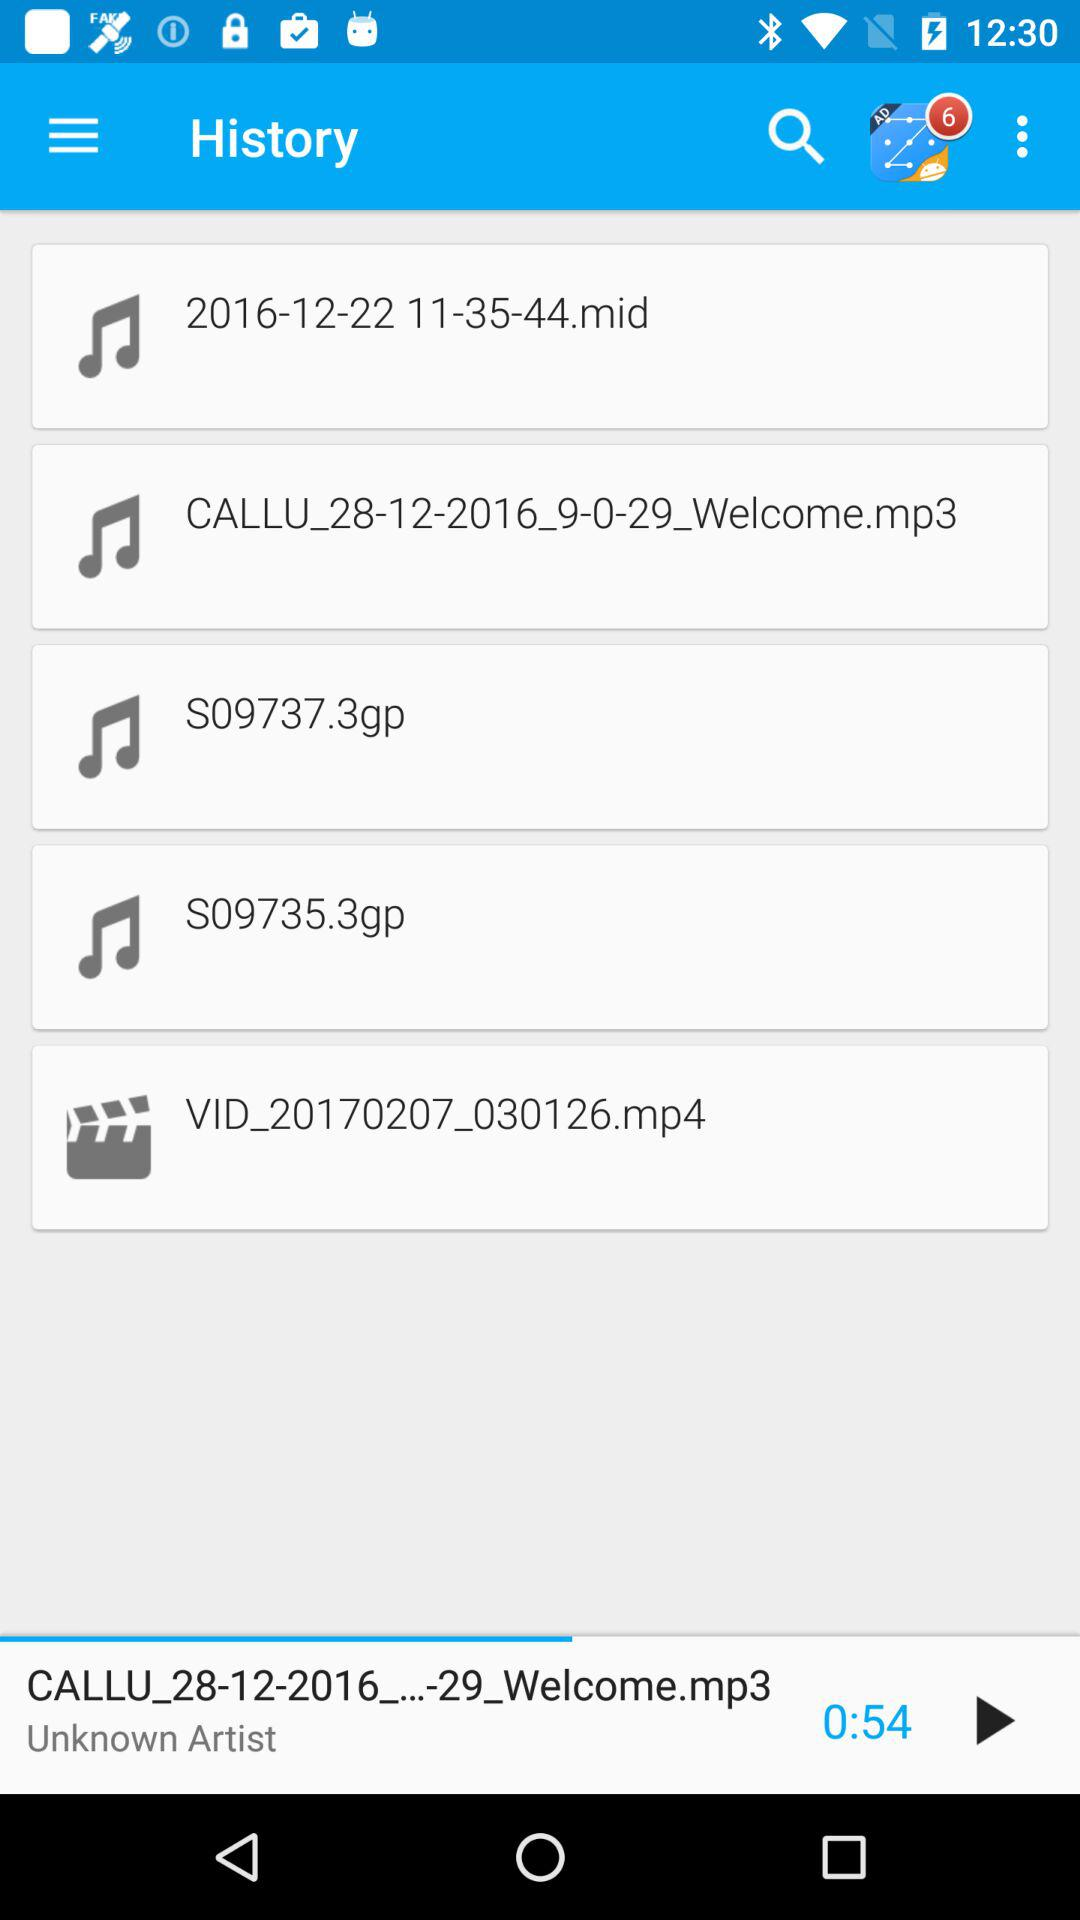Who is the artist of the audio that was last played? The artist of the audio that was last played is unknown. 